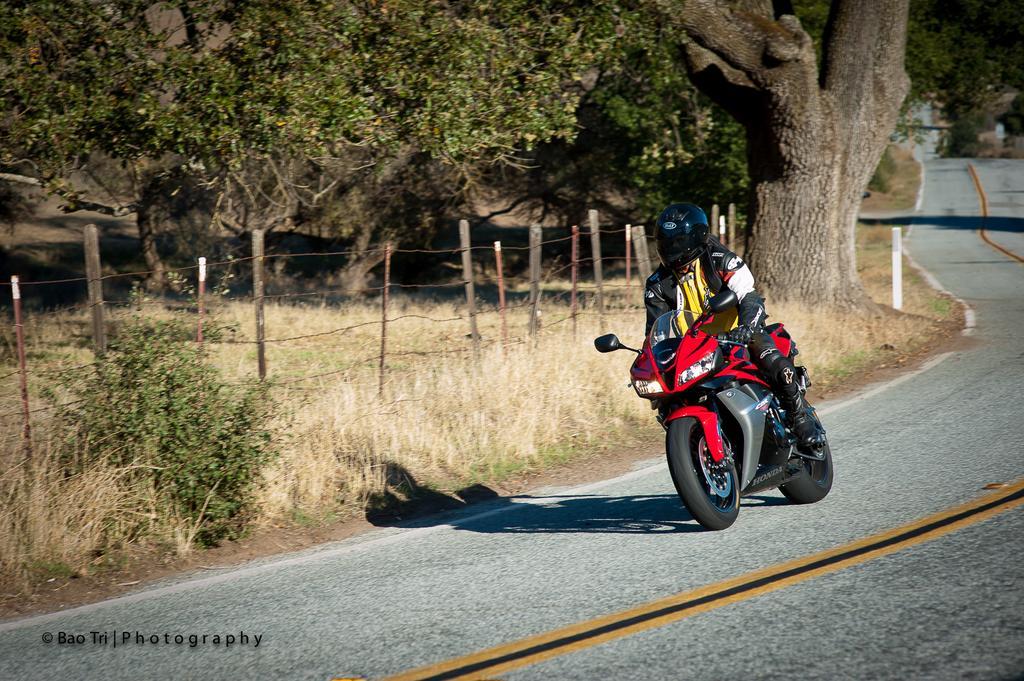Could you give a brief overview of what you see in this image? In this picture I can see a human riding the motorcycle and he is wearing a helmet on his head and I can see plants, trees and grass on the ground and I can see fence and text at the bottom left corner of the picture. 